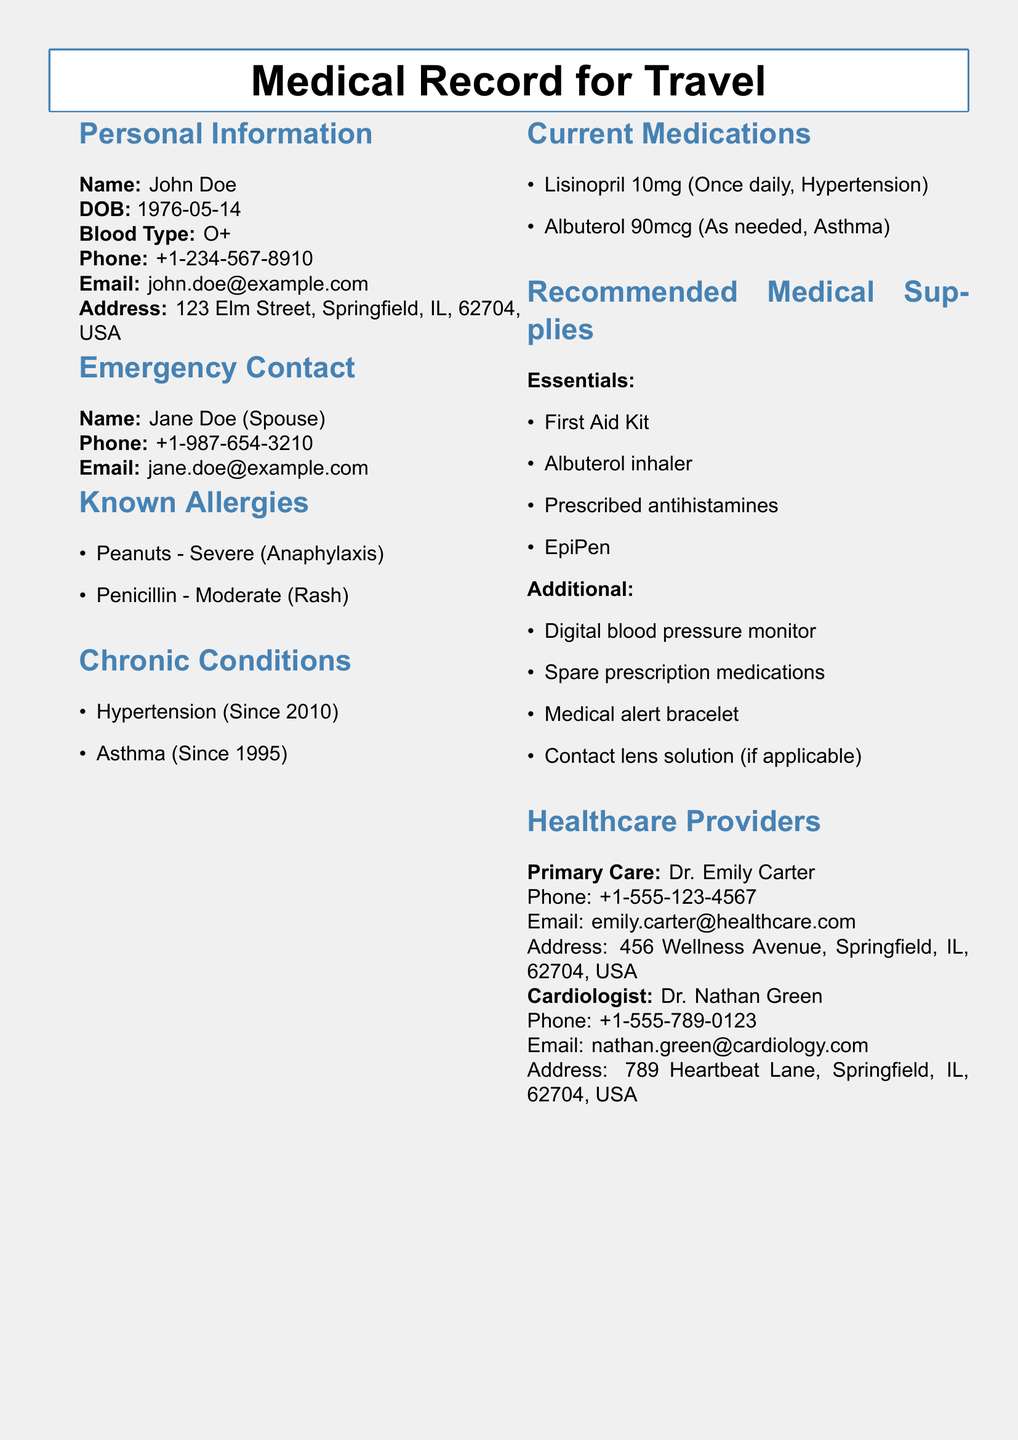What is the name of the patient? The name of the patient is listed under Personal Information.
Answer: John Doe What is the date of birth of the patient? The date of birth is indicated under Personal Information.
Answer: 1976-05-14 What is the blood type of the patient? The blood type can be found in the Personal Information section.
Answer: O+ Who is the emergency contact? The emergency contact's details are provided in the Emergency Contact section.
Answer: Jane Doe (Spouse) What medication is prescribed for hypertension? The current medication for hypertension is mentioned in the Current Medications section.
Answer: Lisinopril 10mg What severe allergy does the patient have? The known allergies are listed; one is classified as severe.
Answer: Peanuts Since what year has the patient had asthma? The chronic conditions list the start year for asthma.
Answer: 1995 What is recommended as an essential medical supply? The Recommended Medical Supplies section lists essentials.
Answer: First Aid Kit Which healthcare provider is the primary care doctor? The primary care doctor's details are outlined in the Healthcare Providers section.
Answer: Dr. Emily Carter What is the phone number of the cardiologist? The phone number for the cardiologist is provided in the Healthcare Providers section.
Answer: +1-555-789-0123 